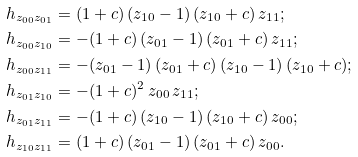Convert formula to latex. <formula><loc_0><loc_0><loc_500><loc_500>h _ { z _ { 0 0 } z _ { 0 1 } } & = ( 1 + c ) \, ( z _ { 1 0 } - 1 ) \, ( z _ { 1 0 } + c ) \, z _ { 1 1 } ; \\ h _ { z _ { 0 0 } z _ { 1 0 } } & = - ( 1 + c ) \, ( z _ { 0 1 } - 1 ) \, ( z _ { 0 1 } + c ) \, z _ { 1 1 } ; \\ h _ { z _ { 0 0 } z _ { 1 1 } } & = - ( z _ { 0 1 } - 1 ) \, ( z _ { 0 1 } + c ) \, ( z _ { 1 0 } - 1 ) \, ( z _ { 1 0 } + c ) ; \\ h _ { z _ { 0 1 } z _ { 1 0 } } & = - ( 1 + c ) ^ { 2 } \, z _ { 0 0 } \, z _ { 1 1 } ; \\ h _ { z _ { 0 1 } z _ { 1 1 } } & = - ( 1 + c ) \, ( z _ { 1 0 } - 1 ) \, ( z _ { 1 0 } + c ) \, z _ { 0 0 } ; \\ h _ { z _ { 1 0 } z _ { 1 1 } } & = ( 1 + c ) \, ( z _ { 0 1 } - 1 ) \, ( z _ { 0 1 } + c ) \, z _ { 0 0 } .</formula> 